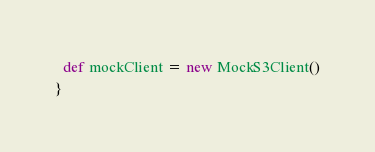<code> <loc_0><loc_0><loc_500><loc_500><_Scala_>  def mockClient = new MockS3Client()
}
</code> 